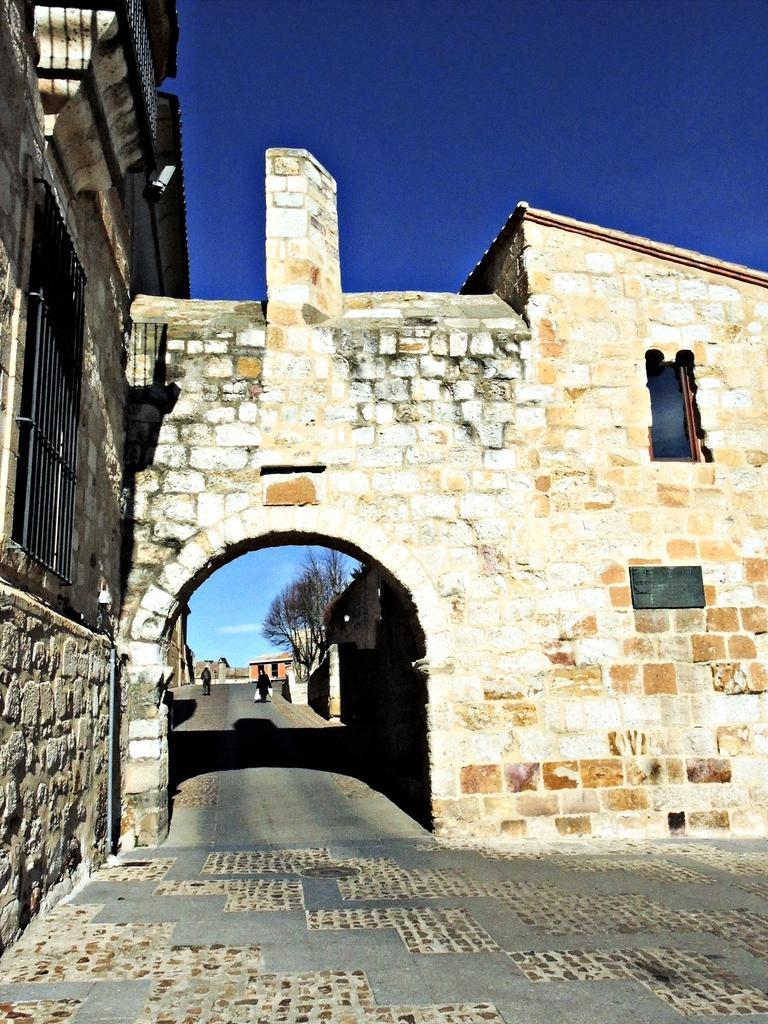Describe this image in one or two sentences. In this image, we can see a building and there is a pole and some trees and sheds and there are some people on the road. At the top, there is sky. 